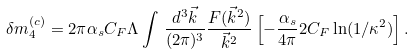<formula> <loc_0><loc_0><loc_500><loc_500>\delta m _ { 4 } ^ { ( c ) } = 2 \pi \alpha _ { s } C _ { F } \Lambda \int \, { \frac { d ^ { 3 } \vec { k } } { ( 2 \pi ) ^ { 3 } } } { \frac { F ( \vec { k } ^ { 2 } ) } { \vec { k } ^ { 2 } } } \left [ - { \frac { \alpha _ { s } } { 4 \pi } } 2 C _ { F } \ln ( 1 / \kappa ^ { 2 } ) \right ] .</formula> 